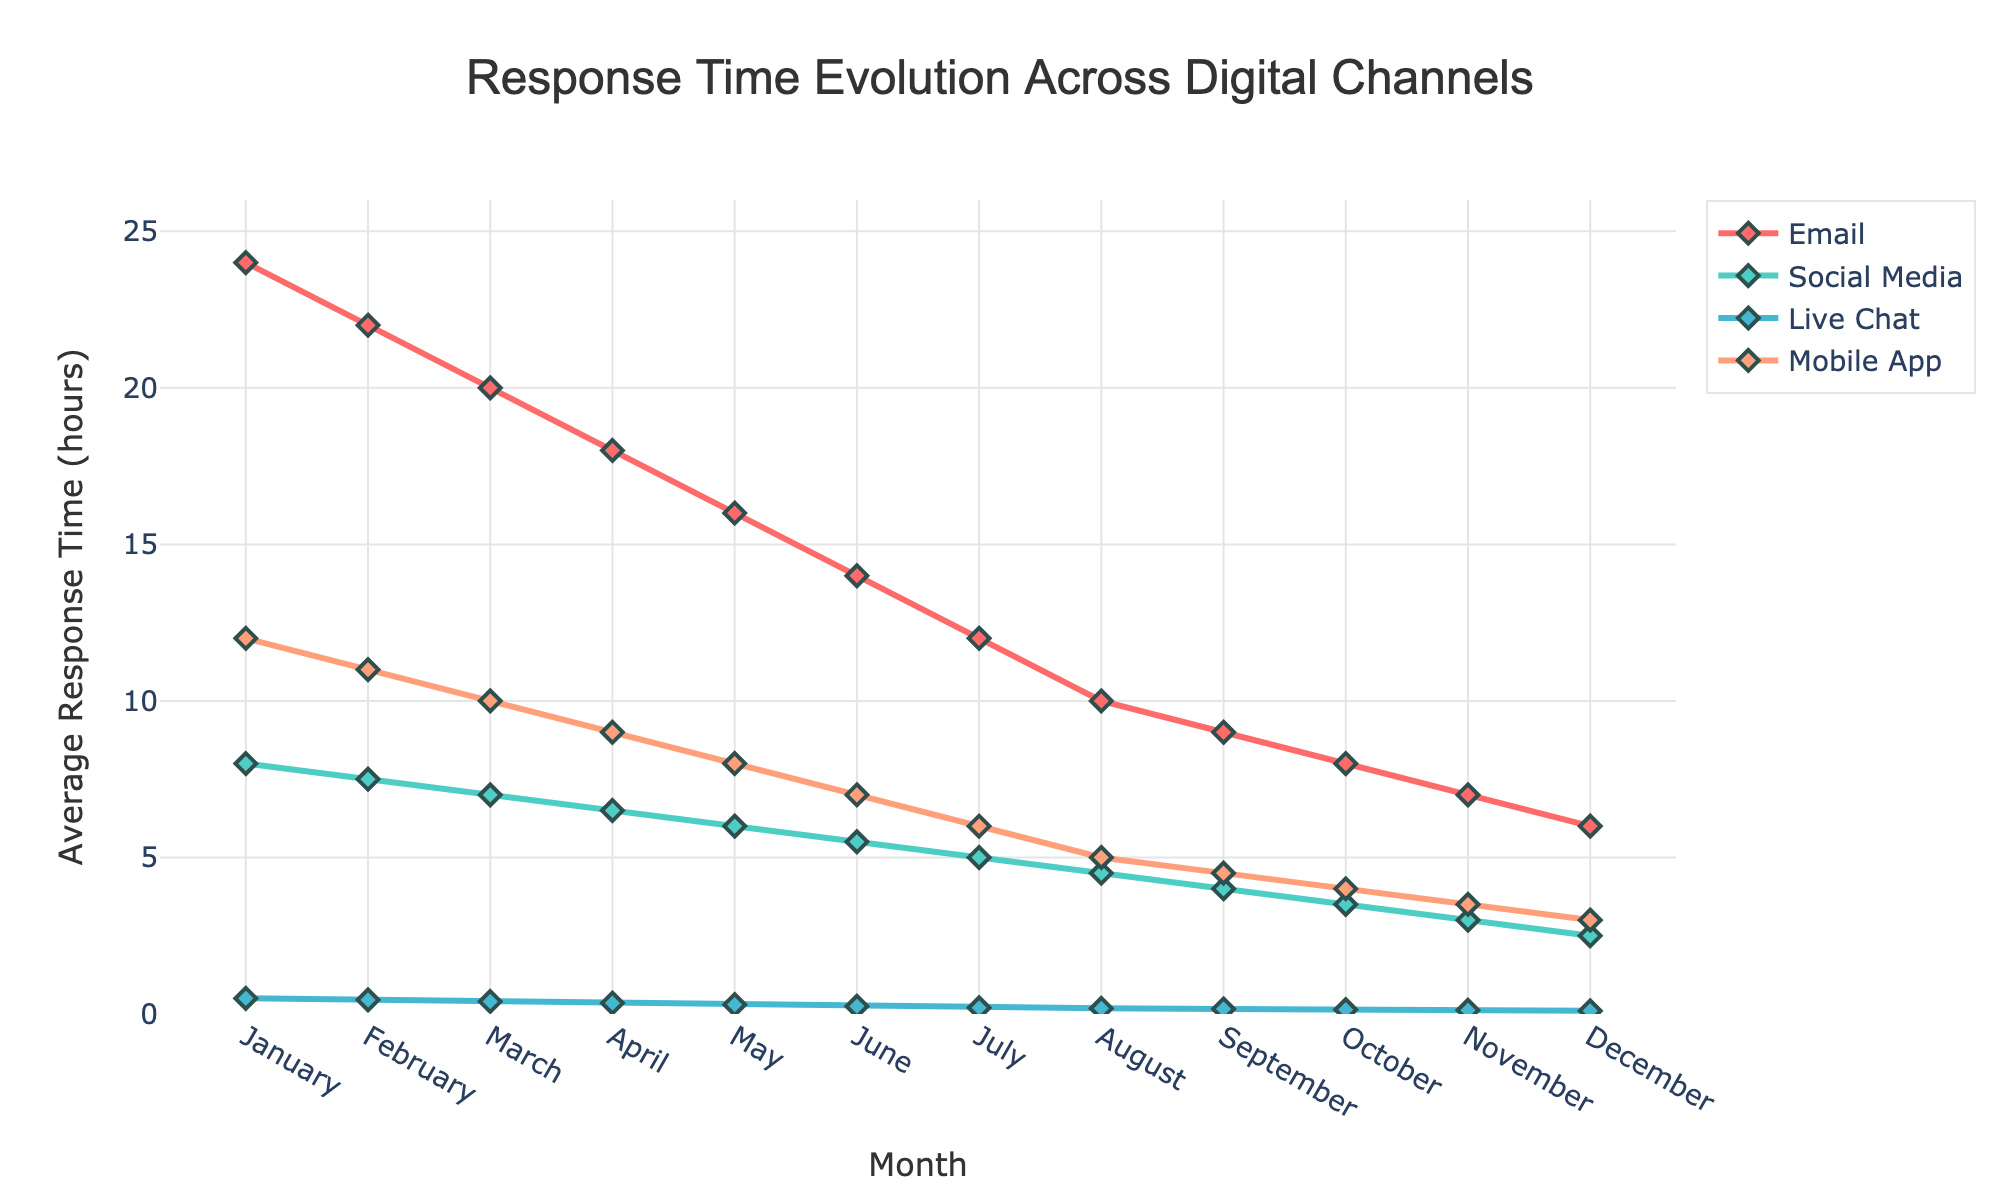What's the general trend of the average response time for emails over the 12 months? Observing the solid line representing emails, we see it starts from the highest point in January and consistently decreases over the months until December. This shows a declining trend throughout the year.
Answer: Decreasing Comparing social media and live chat, which channel showed the fastest response time in December? By looking at the December data points, the line representing live chat is lower than that of social media, showing smaller values on the Y-axis.
Answer: Live chat How does the average response time for mobile app inquiries in July compare to email inquiries in April? Observing the data for July under mobile apps and April under emails, the mobile app response time is 6 hours, and the email response time is 18 hours.
Answer: Mobile app has a shorter response time By how many hours did the average response time for social media improve from January to December? Find the difference between the January and December response times for social media. January is 8 hours, and December is 2.5 hours; the improvement is 8 - 2.5.
Answer: 5.5 hours Which channel experienced the greatest reduction in average response time from January to December? Calculate the reduction for each channel by subtracting the December response time from the January response time and compare them. Email reduced by 18 hours, social media by 5.5 hours, live chat by 0.4 hours, and mobile app by 9 hours.
Answer: Email What is the average of the response times for live chat over the year? Sum all the response times for live chat recorded monthly and divide by the number of months (sum of: 0.5 + 0.45 + 0.4 + ... + 0.1) / 12.
Answer: 0.27 hours Is there any month where the response time for the mobile app is equal to the response time for social media? Check for any matching values in the lists of the response times for social media and the mobile app for each month. Analysis shows no matching values.
Answer: No In which month did all channels have their lowest response times? Find the month where all data points are at their minimum values across different months for each channel. December holds the lowest values for all channels.
Answer: December Did any channel have an increase in average response time over the 12 months? Review all the trends for any upward slope or data points indicating an increase from January to December. All channels show a decrease in response times.
Answer: No 